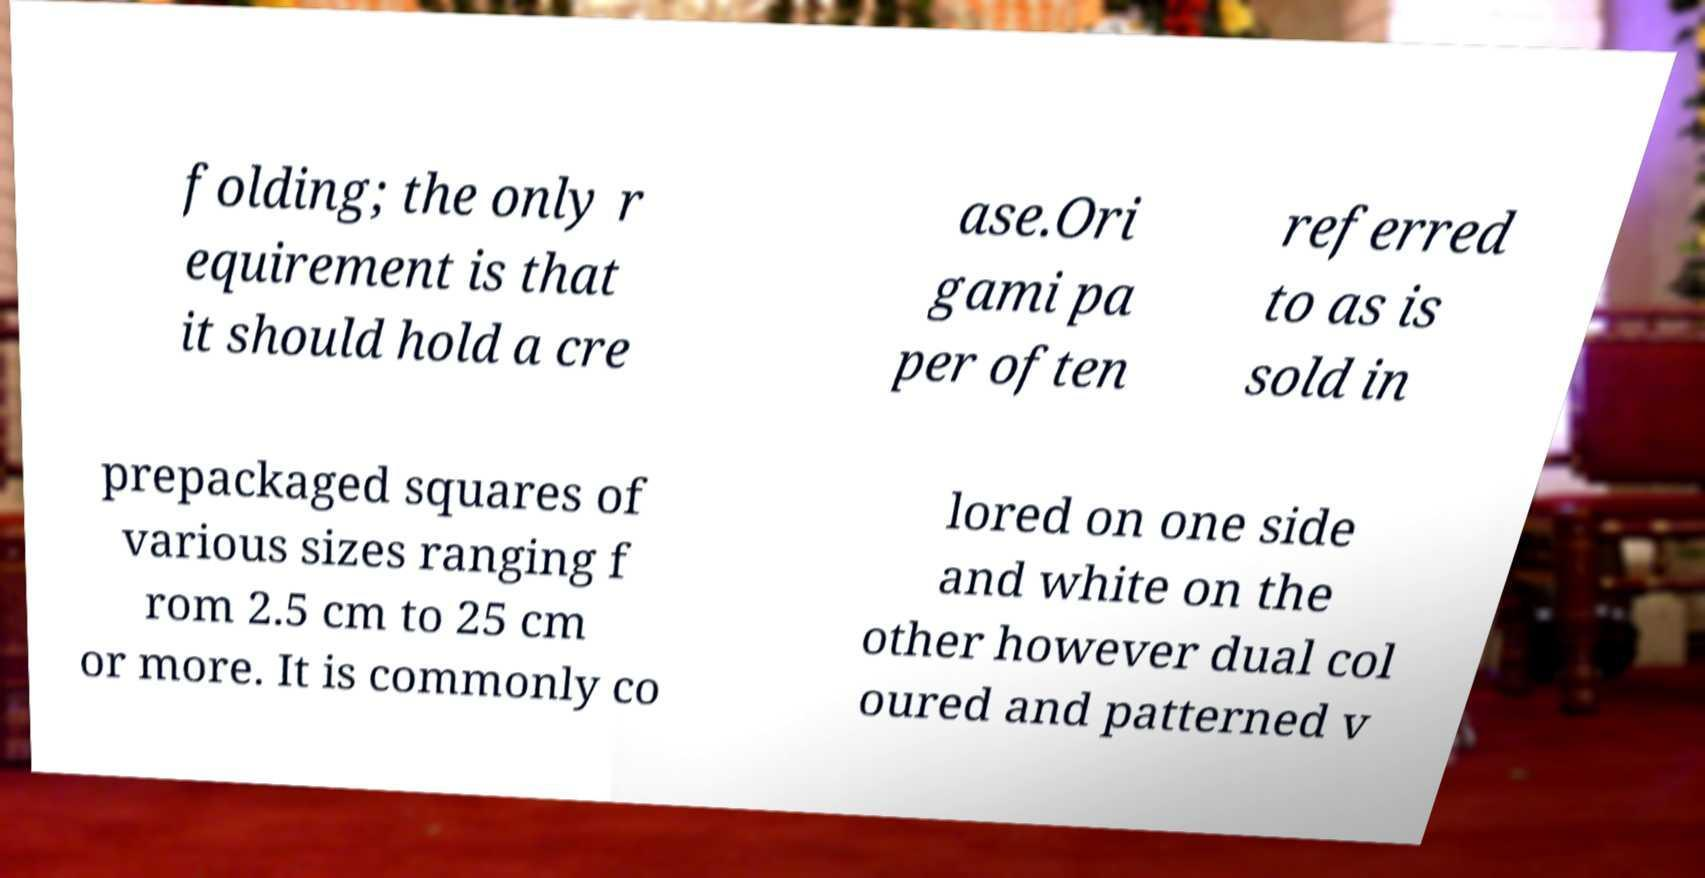Can you accurately transcribe the text from the provided image for me? folding; the only r equirement is that it should hold a cre ase.Ori gami pa per often referred to as is sold in prepackaged squares of various sizes ranging f rom 2.5 cm to 25 cm or more. It is commonly co lored on one side and white on the other however dual col oured and patterned v 